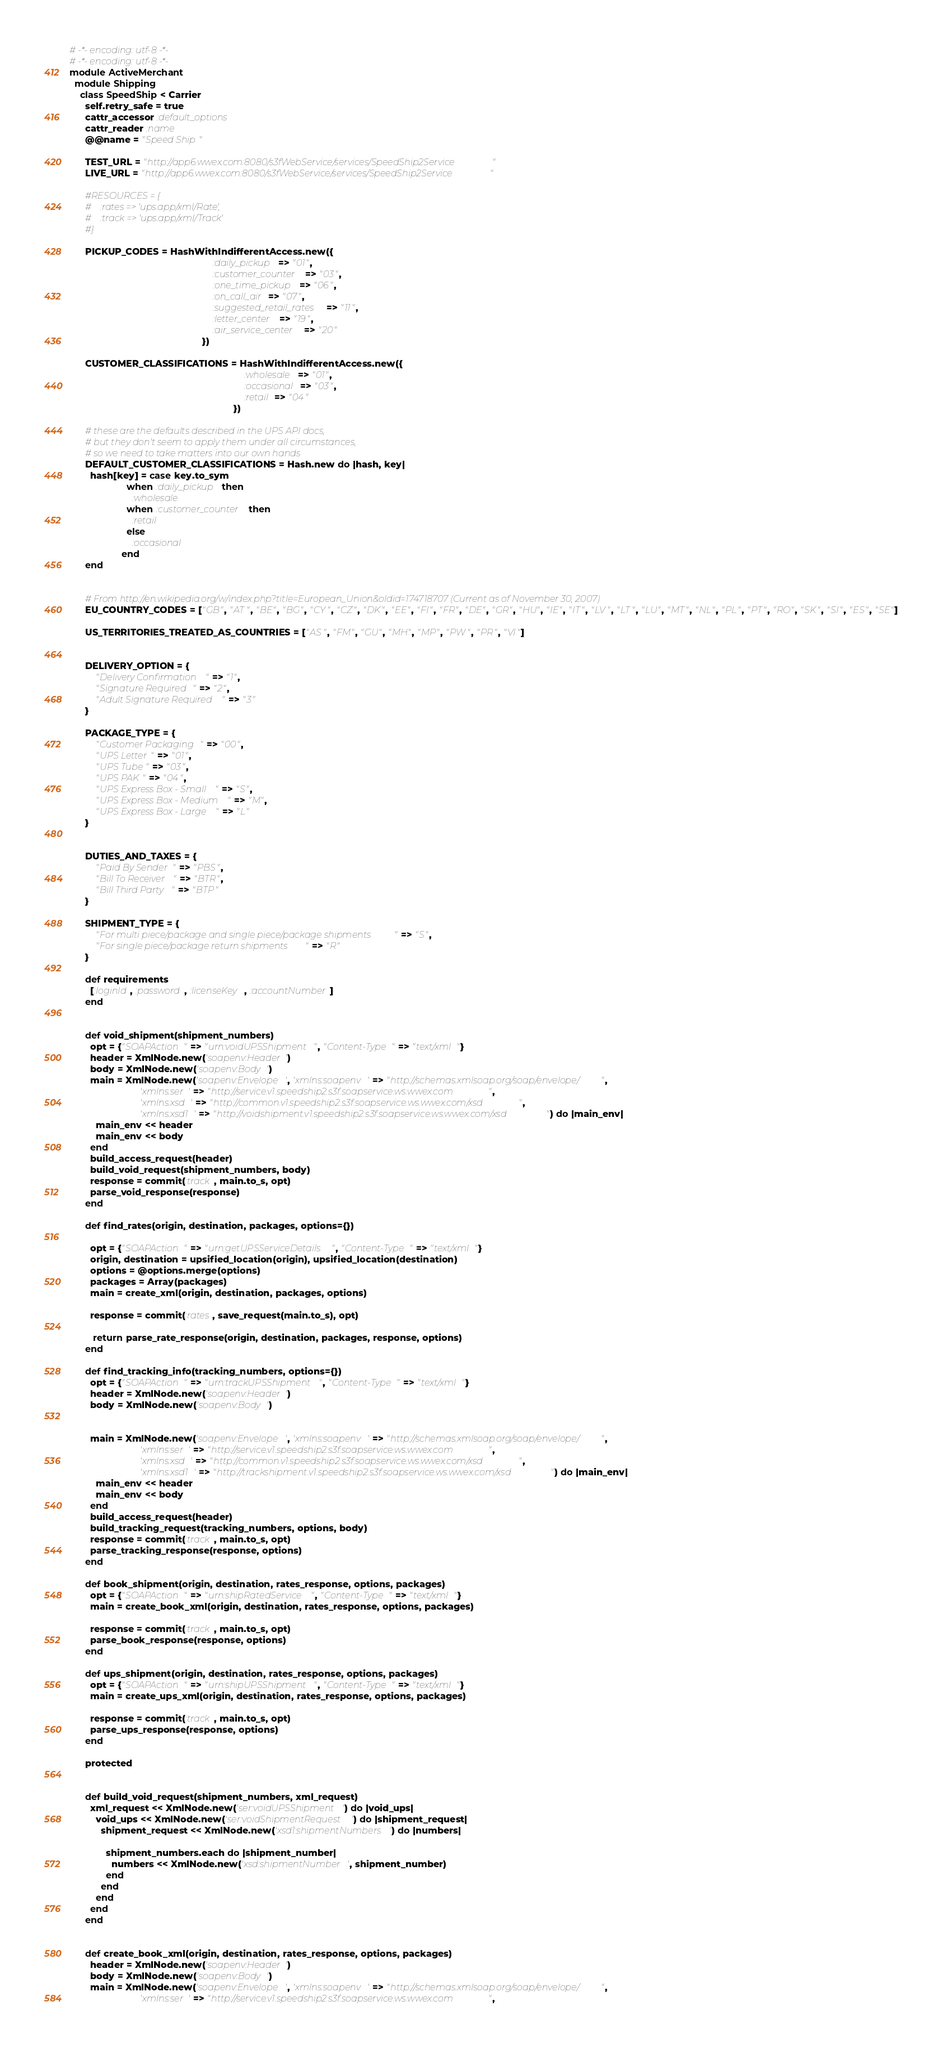Convert code to text. <code><loc_0><loc_0><loc_500><loc_500><_Ruby_># -*- encoding: utf-8 -*-
# -*- encoding: utf-8 -*-
module ActiveMerchant
  module Shipping
    class SpeedShip < Carrier
      self.retry_safe = true
      cattr_accessor :default_options
      cattr_reader :name
      @@name = "Speed Ship"

      TEST_URL = "http://app6.wwex.com:8080/s3fWebService/services/SpeedShip2Service"
      LIVE_URL = "http://app6.wwex.com:8080/s3fWebService/services/SpeedShip2Service"

      #RESOURCES = {
      #    :rates => 'ups.app/xml/Rate',
      #    :track => 'ups.app/xml/Track'
      #}

      PICKUP_CODES = HashWithIndifferentAccess.new({
                                                       :daily_pickup => "01",
                                                       :customer_counter => "03",
                                                       :one_time_pickup => "06",
                                                       :on_call_air => "07",
                                                       :suggested_retail_rates => "11",
                                                       :letter_center => "19",
                                                       :air_service_center => "20"
                                                   })

      CUSTOMER_CLASSIFICATIONS = HashWithIndifferentAccess.new({
                                                                   :wholesale => "01",
                                                                   :occasional => "03",
                                                                   :retail => "04"
                                                               })

      # these are the defaults described in the UPS API docs,
      # but they don't seem to apply them under all circumstances,
      # so we need to take matters into our own hands
      DEFAULT_CUSTOMER_CLASSIFICATIONS = Hash.new do |hash, key|
        hash[key] = case key.to_sym
                      when :daily_pickup then
                        :wholesale
                      when :customer_counter then
                        :retail
                      else
                        :occasional
                    end
      end


      # From http://en.wikipedia.org/w/index.php?title=European_Union&oldid=174718707 (Current as of November 30, 2007)
      EU_COUNTRY_CODES = ["GB", "AT", "BE", "BG", "CY", "CZ", "DK", "EE", "FI", "FR", "DE", "GR", "HU", "IE", "IT", "LV", "LT", "LU", "MT", "NL", "PL", "PT", "RO", "SK", "SI", "ES", "SE"]

      US_TERRITORIES_TREATED_AS_COUNTRIES = ["AS", "FM", "GU", "MH", "MP", "PW", "PR", "VI"]


      DELIVERY_OPTION = {
          "Delivery Confirmation" => "1",
          "Signature Required" => "2",
          "Adult Signature Required" => "3"
      }

      PACKAGE_TYPE = {
          "Customer Packaging" => "00",
          "UPS Letter" => "01",
          "UPS Tube" => "03",
          "UPS PAK" => "04",
          "UPS Express Box - Small" => "S",
          "UPS Express Box - Medium" => "M",
          "UPS Express Box - Large" => "L"
      }


      DUTIES_AND_TAXES = {
          "Paid By Sender" => "PBS",
          "Bill To Receiver" => "BTR",
          "Bill Third Party" => "BTP"
      }

      SHIPMENT_TYPE = {
          "For multi piece/package and single piece/package shipments" => "S",
          "For single piece/package return shipments" => "R"
      }

      def requirements
        [:loginId, :password, :licenseKey, :accountNumber]
      end


      def void_shipment(shipment_numbers)
        opt = {"SOAPAction" => "urn:voidUPSShipment", "Content-Type" => "text/xml"}
        header = XmlNode.new('soapenv:Header')
        body = XmlNode.new('soapenv:Body')
        main = XmlNode.new('soapenv:Envelope', 'xmlns:soapenv' => "http://schemas.xmlsoap.org/soap/envelope/",
                           'xmlns:ser' => "http://service.v1.speedship2.s3f.soapservice.ws.wwex.com",
                           'xmlns:xsd' => "http://common.v1.speedship2.s3f.soapservice.ws.wwex.com/xsd",
                           'xmlns:xsd1' => "http://voidshipment.v1.speedship2.s3f.soapservice.ws.wwex.com/xsd") do |main_env|
          main_env << header
          main_env << body
        end
        build_access_request(header)
        build_void_request(shipment_numbers, body)
        response = commit(:track, main.to_s, opt)
        parse_void_response(response)
      end

      def find_rates(origin, destination, packages, options={})

        opt = {"SOAPAction" => "urn:getUPSServiceDetails", "Content-Type" => "text/xml"}
        origin, destination = upsified_location(origin), upsified_location(destination)
        options = @options.merge(options)
        packages = Array(packages)
        main = create_xml(origin, destination, packages, options)

        response = commit(:rates, save_request(main.to_s), opt)

         return parse_rate_response(origin, destination, packages, response, options)
      end

      def find_tracking_info(tracking_numbers, options={})
        opt = {"SOAPAction" => "urn:trackUPSShipment", "Content-Type" => "text/xml"}
        header = XmlNode.new('soapenv:Header')
        body = XmlNode.new('soapenv:Body')


        main = XmlNode.new('soapenv:Envelope', 'xmlns:soapenv' => "http://schemas.xmlsoap.org/soap/envelope/",
                           'xmlns:ser' => "http://service.v1.speedship2.s3f.soapservice.ws.wwex.com",
                           'xmlns:xsd' => "http://common.v1.speedship2.s3f.soapservice.ws.wwex.com/xsd",
                           'xmlns:xsd1' => "http://trackshipment.v1.speedship2.s3f.soapservice.ws.wwex.com/xsd") do |main_env|
          main_env << header
          main_env << body
        end
        build_access_request(header)
        build_tracking_request(tracking_numbers, options, body)
        response = commit(:track, main.to_s, opt)
        parse_tracking_response(response, options)
      end

      def book_shipment(origin, destination, rates_response, options, packages)
        opt = {"SOAPAction" => "urn:shipRatedService", "Content-Type" => "text/xml"}
        main = create_book_xml(origin, destination, rates_response, options, packages)

        response = commit(:track, main.to_s, opt)
        parse_book_response(response, options)
      end

      def ups_shipment(origin, destination, rates_response, options, packages)
        opt = {"SOAPAction" => "urn:shipUPSShipment", "Content-Type" => "text/xml"}
        main = create_ups_xml(origin, destination, rates_response, options, packages)

        response = commit(:track, main.to_s, opt)
        parse_ups_response(response, options)
      end

      protected


      def build_void_request(shipment_numbers, xml_request)
        xml_request << XmlNode.new('ser:voidUPSShipment') do |void_ups|
          void_ups << XmlNode.new('ser:voidShipmentRequest') do |shipment_request|
            shipment_request << XmlNode.new('xsd1:shipmentNumbers') do |numbers|

              shipment_numbers.each do |shipment_number|
                numbers << XmlNode.new('xsd:shipmentNumber', shipment_number)
              end
            end
          end
        end
      end


      def create_book_xml(origin, destination, rates_response, options, packages)
        header = XmlNode.new('soapenv:Header')
        body = XmlNode.new('soapenv:Body')
        main = XmlNode.new('soapenv:Envelope', 'xmlns:soapenv' => "http://schemas.xmlsoap.org/soap/envelope/",
                           'xmlns:ser' => "http://service.v1.speedship2.s3f.soapservice.ws.wwex.com",</code> 